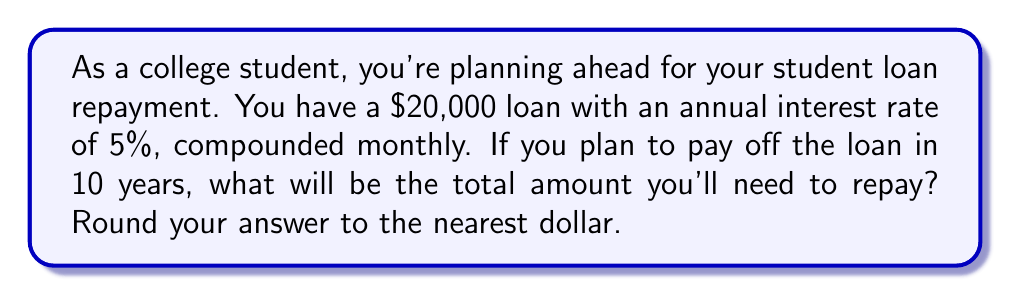Show me your answer to this math problem. Let's approach this step-by-step using the compound interest formula:

1) The compound interest formula is:
   $A = P(1 + \frac{r}{n})^{nt}$

   Where:
   $A$ = final amount
   $P$ = principal (initial loan amount)
   $r$ = annual interest rate (in decimal form)
   $n$ = number of times interest is compounded per year
   $t$ = number of years

2) We know:
   $P = 20,000$
   $r = 0.05$ (5% in decimal form)
   $n = 12$ (compounded monthly)
   $t = 10$ years

3) Let's substitute these values into the formula:

   $A = 20,000(1 + \frac{0.05}{12})^{12 * 10}$

4) Simplify inside the parentheses:
   $A = 20,000(1 + 0.004167)^{120}$

5) Calculate:
   $A = 20,000(1.004167)^{120}$
   $A = 20,000(1.6386)$
   $A = 32,771.69$

6) Rounding to the nearest dollar:
   $A ≈ 32,772$

Therefore, the total amount you'll need to repay after 10 years is $32,772.
Answer: $32,772 